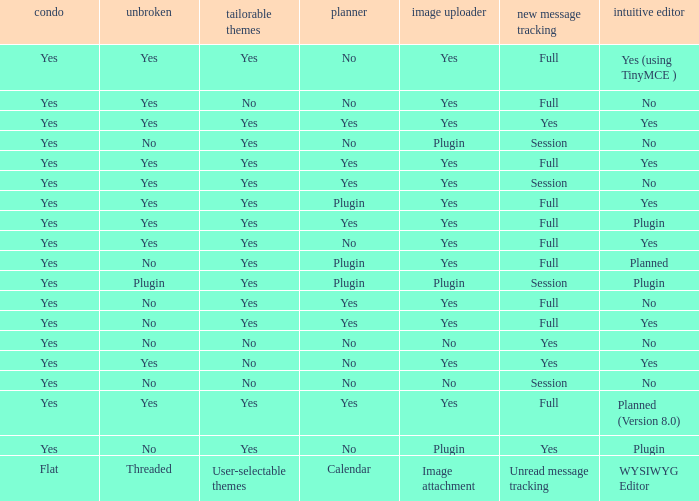Which Calendar has a WYSIWYG Editor of no, and an Unread message tracking of session, and an Image attachment of no? No. 